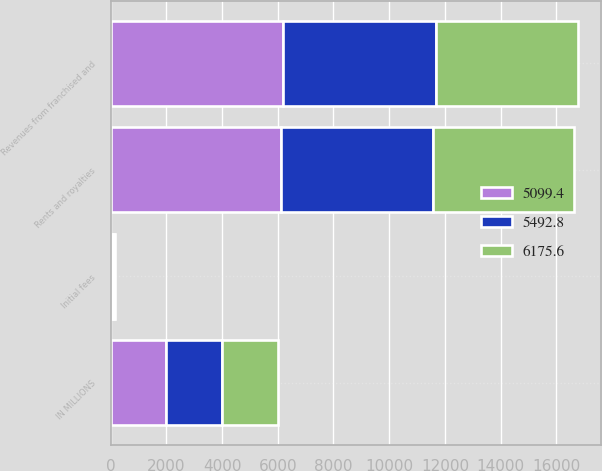Convert chart. <chart><loc_0><loc_0><loc_500><loc_500><stacked_bar_chart><ecel><fcel>IN MILLIONS<fcel>Rents and royalties<fcel>Initial fees<fcel>Revenues from franchised and<nl><fcel>5099.4<fcel>2007<fcel>6118.3<fcel>57.3<fcel>6175.6<nl><fcel>5492.8<fcel>2006<fcel>5441.3<fcel>51.5<fcel>5492.8<nl><fcel>6175.6<fcel>2005<fcel>5061.4<fcel>38<fcel>5099.4<nl></chart> 